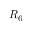<formula> <loc_0><loc_0><loc_500><loc_500>R _ { 6 }</formula> 